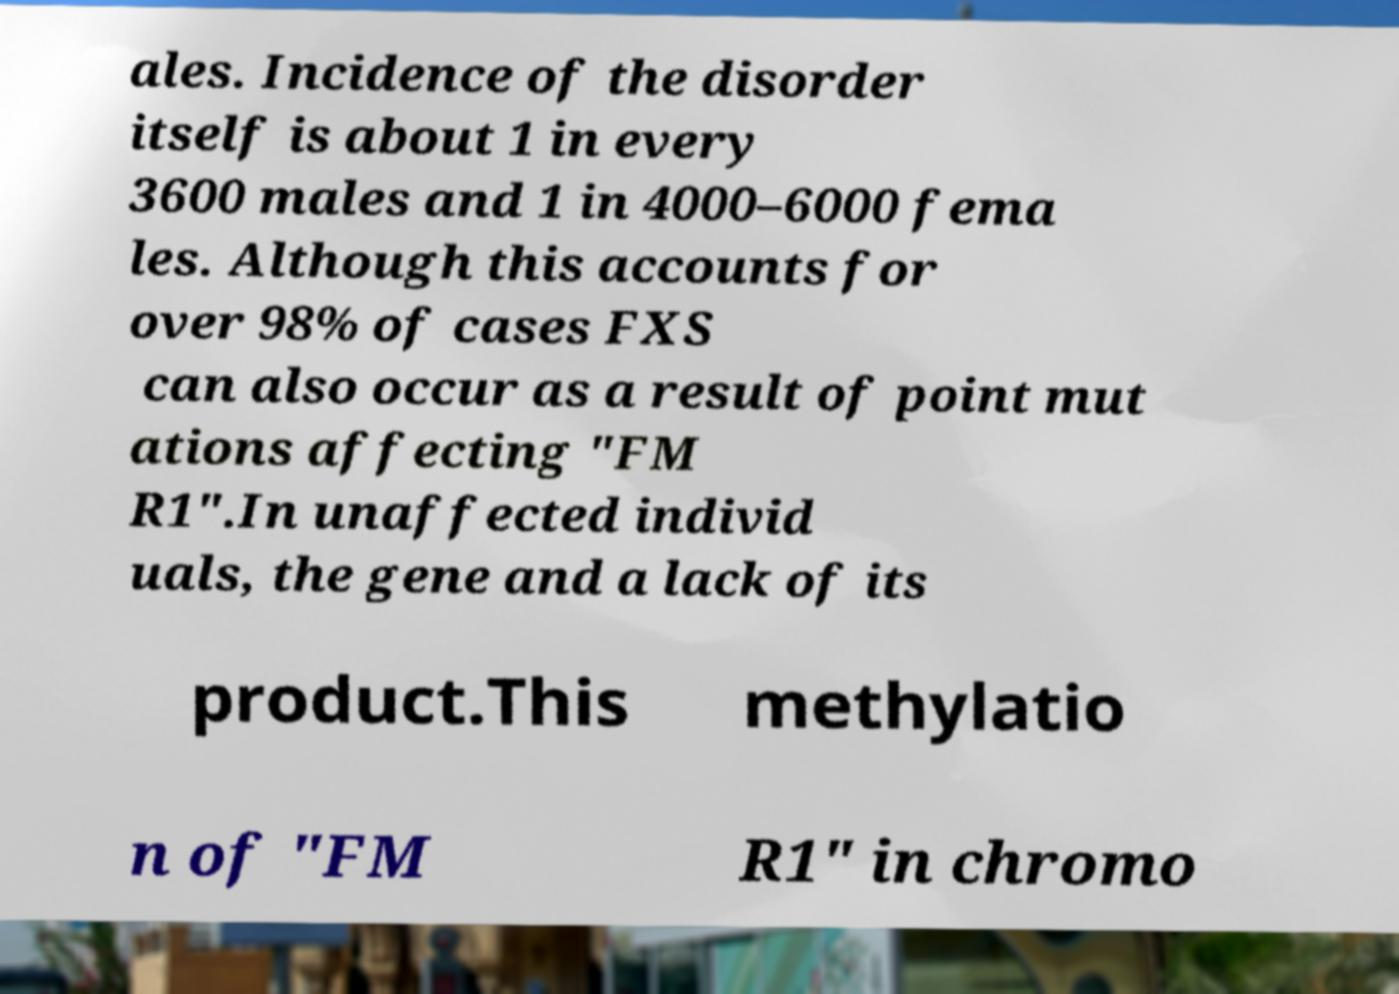There's text embedded in this image that I need extracted. Can you transcribe it verbatim? ales. Incidence of the disorder itself is about 1 in every 3600 males and 1 in 4000–6000 fema les. Although this accounts for over 98% of cases FXS can also occur as a result of point mut ations affecting "FM R1".In unaffected individ uals, the gene and a lack of its product.This methylatio n of "FM R1" in chromo 